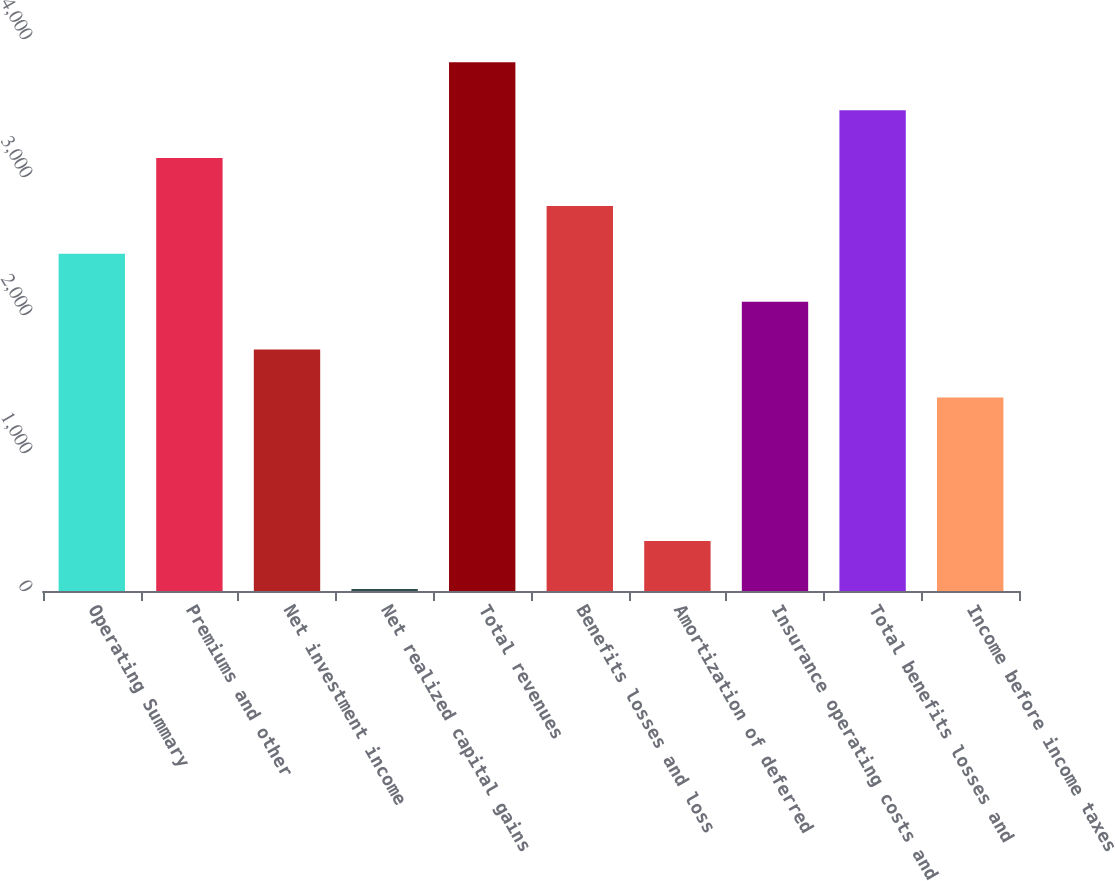Convert chart. <chart><loc_0><loc_0><loc_500><loc_500><bar_chart><fcel>Operating Summary<fcel>Premiums and other<fcel>Net investment income<fcel>Net realized capital gains<fcel>Total revenues<fcel>Benefits losses and loss<fcel>Amortization of deferred<fcel>Insurance operating costs and<fcel>Total benefits losses and<fcel>Income before income taxes<nl><fcel>2443.3<fcel>3137.1<fcel>1749.5<fcel>15<fcel>3830.9<fcel>2790.2<fcel>361.9<fcel>2096.4<fcel>3484<fcel>1402.6<nl></chart> 